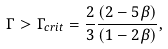Convert formula to latex. <formula><loc_0><loc_0><loc_500><loc_500>\Gamma > \Gamma _ { c r i t } = \frac { 2 } { 3 } \frac { ( 2 - 5 \beta ) } { ( 1 - 2 \beta ) } ,</formula> 